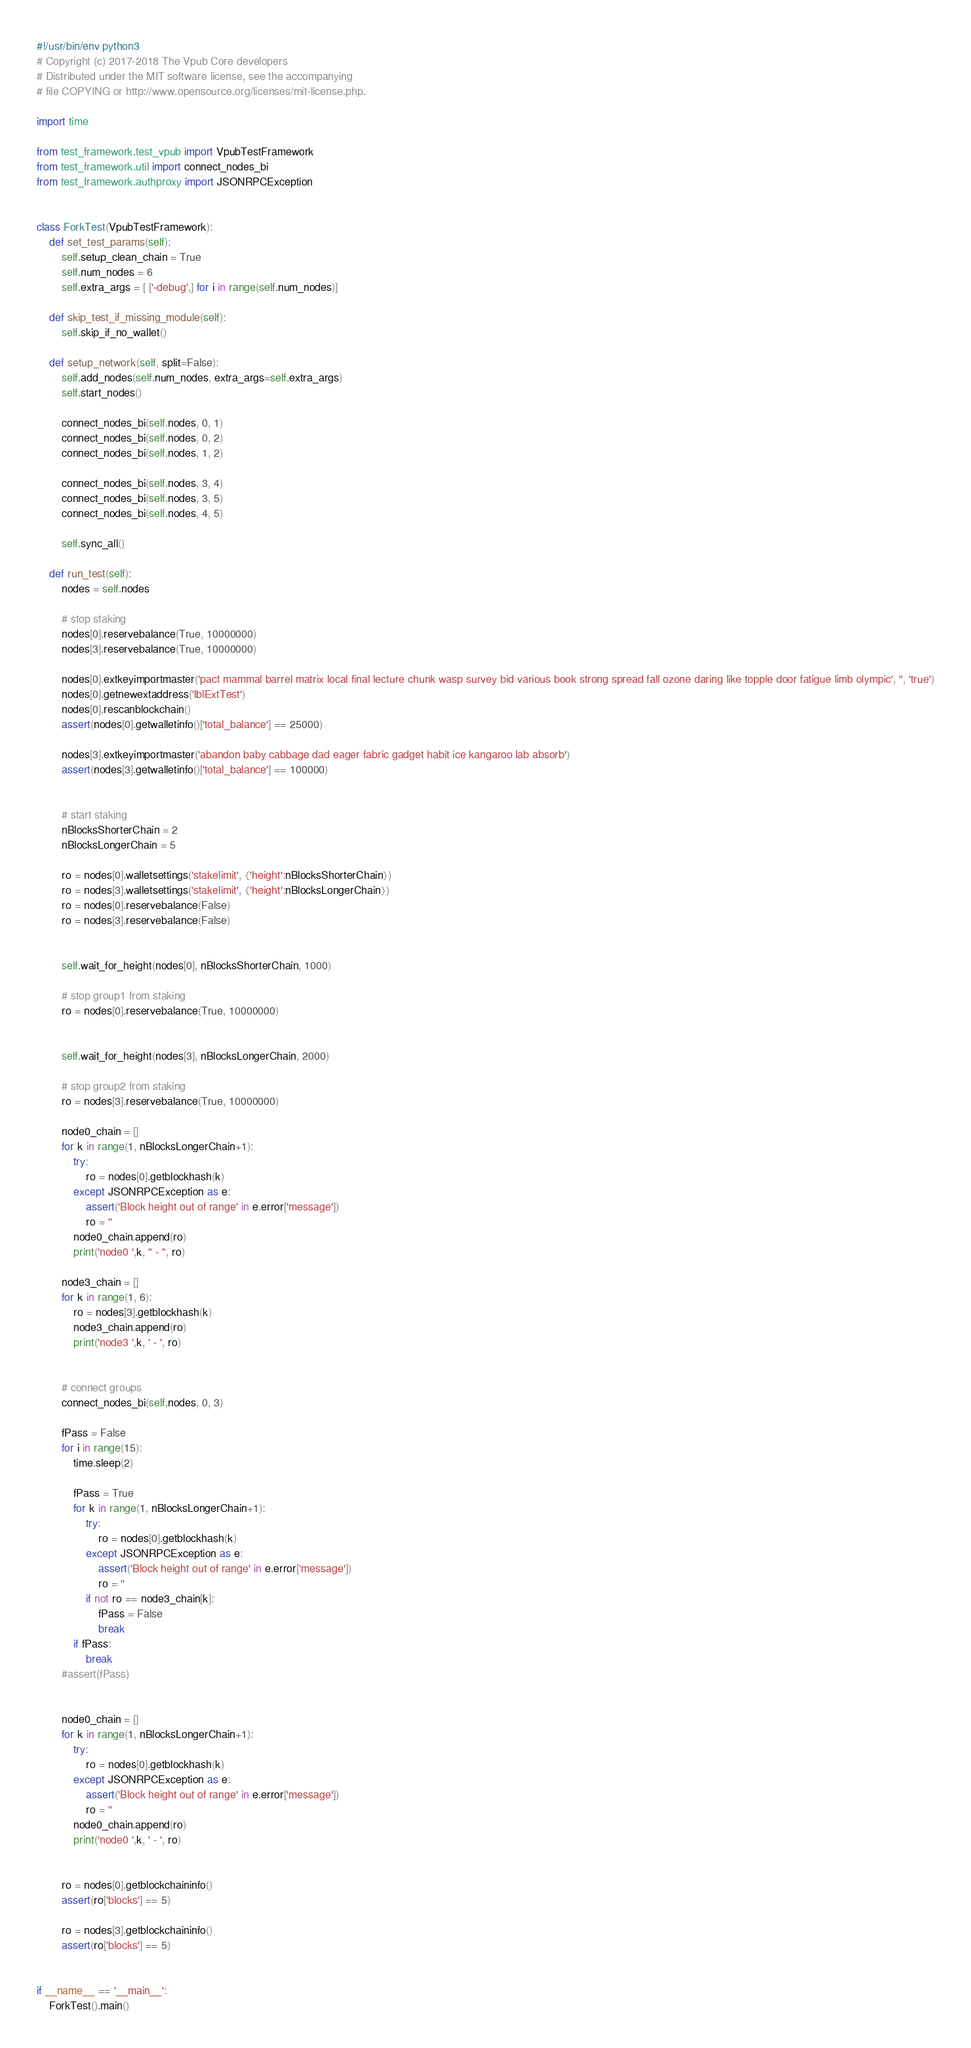Convert code to text. <code><loc_0><loc_0><loc_500><loc_500><_Python_>#!/usr/bin/env python3
# Copyright (c) 2017-2018 The Vpub Core developers
# Distributed under the MIT software license, see the accompanying
# file COPYING or http://www.opensource.org/licenses/mit-license.php.

import time

from test_framework.test_vpub import VpubTestFramework
from test_framework.util import connect_nodes_bi
from test_framework.authproxy import JSONRPCException


class ForkTest(VpubTestFramework):
    def set_test_params(self):
        self.setup_clean_chain = True
        self.num_nodes = 6
        self.extra_args = [ ['-debug',] for i in range(self.num_nodes)]

    def skip_test_if_missing_module(self):
        self.skip_if_no_wallet()

    def setup_network(self, split=False):
        self.add_nodes(self.num_nodes, extra_args=self.extra_args)
        self.start_nodes()

        connect_nodes_bi(self.nodes, 0, 1)
        connect_nodes_bi(self.nodes, 0, 2)
        connect_nodes_bi(self.nodes, 1, 2)

        connect_nodes_bi(self.nodes, 3, 4)
        connect_nodes_bi(self.nodes, 3, 5)
        connect_nodes_bi(self.nodes, 4, 5)

        self.sync_all()

    def run_test(self):
        nodes = self.nodes

        # stop staking
        nodes[0].reservebalance(True, 10000000)
        nodes[3].reservebalance(True, 10000000)

        nodes[0].extkeyimportmaster('pact mammal barrel matrix local final lecture chunk wasp survey bid various book strong spread fall ozone daring like topple door fatigue limb olympic', '', 'true')
        nodes[0].getnewextaddress('lblExtTest')
        nodes[0].rescanblockchain()
        assert(nodes[0].getwalletinfo()['total_balance'] == 25000)

        nodes[3].extkeyimportmaster('abandon baby cabbage dad eager fabric gadget habit ice kangaroo lab absorb')
        assert(nodes[3].getwalletinfo()['total_balance'] == 100000)


        # start staking
        nBlocksShorterChain = 2
        nBlocksLongerChain = 5

        ro = nodes[0].walletsettings('stakelimit', {'height':nBlocksShorterChain})
        ro = nodes[3].walletsettings('stakelimit', {'height':nBlocksLongerChain})
        ro = nodes[0].reservebalance(False)
        ro = nodes[3].reservebalance(False)


        self.wait_for_height(nodes[0], nBlocksShorterChain, 1000)

        # stop group1 from staking
        ro = nodes[0].reservebalance(True, 10000000)


        self.wait_for_height(nodes[3], nBlocksLongerChain, 2000)

        # stop group2 from staking
        ro = nodes[3].reservebalance(True, 10000000)

        node0_chain = []
        for k in range(1, nBlocksLongerChain+1):
            try:
                ro = nodes[0].getblockhash(k)
            except JSONRPCException as e:
                assert('Block height out of range' in e.error['message'])
                ro = ''
            node0_chain.append(ro)
            print('node0 ',k, " - ", ro)

        node3_chain = []
        for k in range(1, 6):
            ro = nodes[3].getblockhash(k)
            node3_chain.append(ro)
            print('node3 ',k, ' - ', ro)


        # connect groups
        connect_nodes_bi(self.nodes, 0, 3)

        fPass = False
        for i in range(15):
            time.sleep(2)

            fPass = True
            for k in range(1, nBlocksLongerChain+1):
                try:
                    ro = nodes[0].getblockhash(k)
                except JSONRPCException as e:
                    assert('Block height out of range' in e.error['message'])
                    ro = ''
                if not ro == node3_chain[k]:
                    fPass = False
                    break
            if fPass:
                break
        #assert(fPass)


        node0_chain = []
        for k in range(1, nBlocksLongerChain+1):
            try:
                ro = nodes[0].getblockhash(k)
            except JSONRPCException as e:
                assert('Block height out of range' in e.error['message'])
                ro = ''
            node0_chain.append(ro)
            print('node0 ',k, ' - ', ro)


        ro = nodes[0].getblockchaininfo()
        assert(ro['blocks'] == 5)

        ro = nodes[3].getblockchaininfo()
        assert(ro['blocks'] == 5)


if __name__ == '__main__':
    ForkTest().main()
</code> 